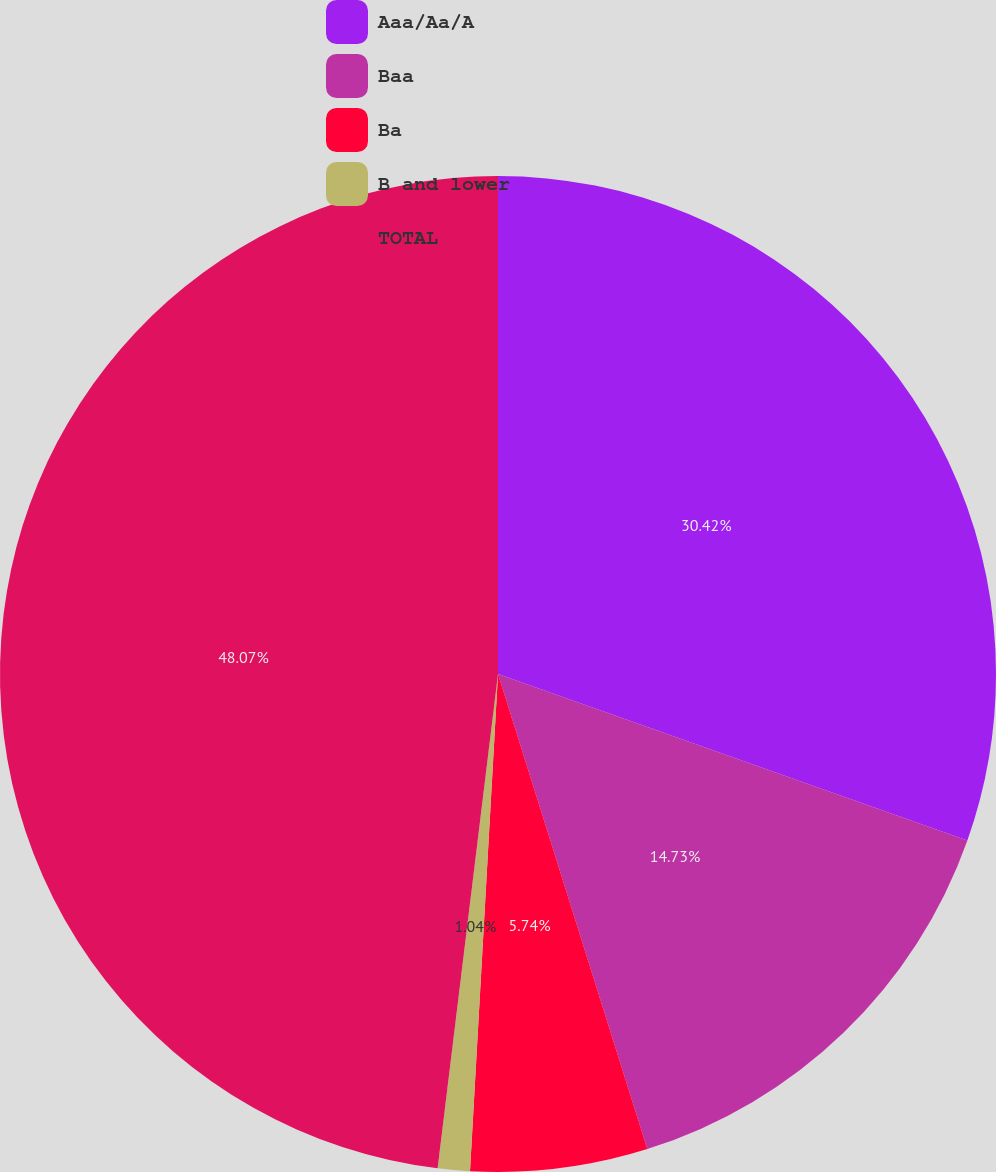<chart> <loc_0><loc_0><loc_500><loc_500><pie_chart><fcel>Aaa/Aa/A<fcel>Baa<fcel>Ba<fcel>B and lower<fcel>TOTAL<nl><fcel>30.42%<fcel>14.73%<fcel>5.74%<fcel>1.04%<fcel>48.06%<nl></chart> 